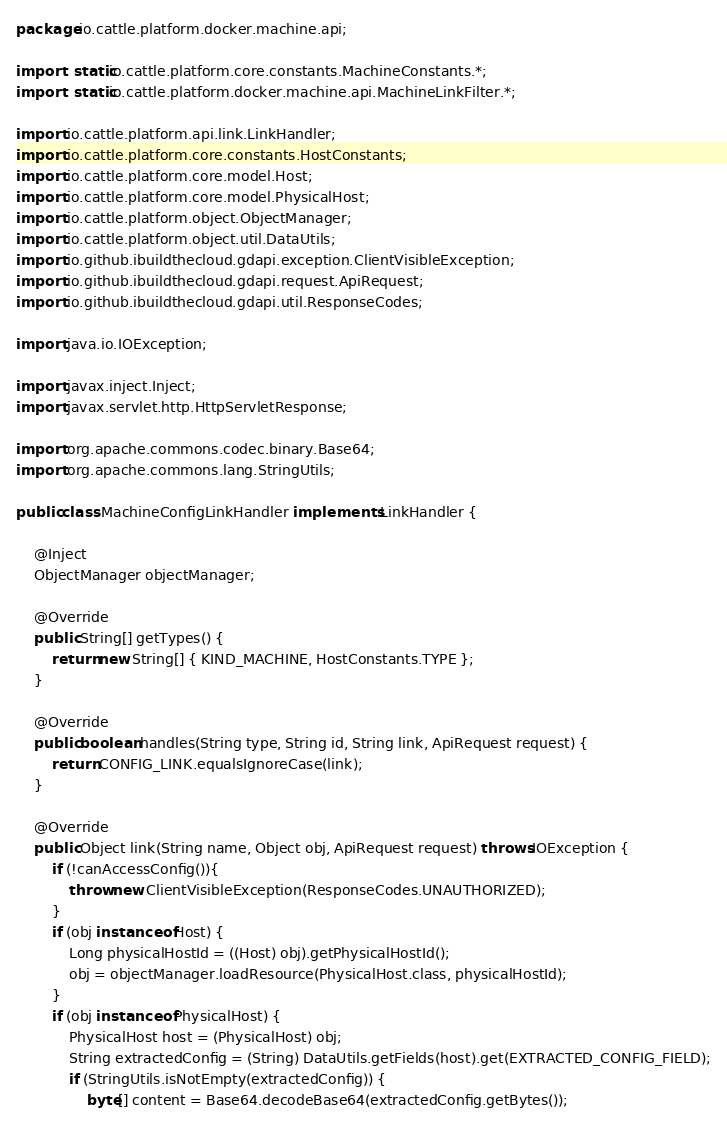<code> <loc_0><loc_0><loc_500><loc_500><_Java_>package io.cattle.platform.docker.machine.api;

import static io.cattle.platform.core.constants.MachineConstants.*;
import static io.cattle.platform.docker.machine.api.MachineLinkFilter.*;

import io.cattle.platform.api.link.LinkHandler;
import io.cattle.platform.core.constants.HostConstants;
import io.cattle.platform.core.model.Host;
import io.cattle.platform.core.model.PhysicalHost;
import io.cattle.platform.object.ObjectManager;
import io.cattle.platform.object.util.DataUtils;
import io.github.ibuildthecloud.gdapi.exception.ClientVisibleException;
import io.github.ibuildthecloud.gdapi.request.ApiRequest;
import io.github.ibuildthecloud.gdapi.util.ResponseCodes;

import java.io.IOException;

import javax.inject.Inject;
import javax.servlet.http.HttpServletResponse;

import org.apache.commons.codec.binary.Base64;
import org.apache.commons.lang.StringUtils;

public class MachineConfigLinkHandler implements LinkHandler {

    @Inject
    ObjectManager objectManager;

    @Override
    public String[] getTypes() {
        return new String[] { KIND_MACHINE, HostConstants.TYPE };
    }

    @Override
    public boolean handles(String type, String id, String link, ApiRequest request) {
        return CONFIG_LINK.equalsIgnoreCase(link);
    }

    @Override
    public Object link(String name, Object obj, ApiRequest request) throws IOException {
        if (!canAccessConfig()){
            throw new ClientVisibleException(ResponseCodes.UNAUTHORIZED);
        }
        if (obj instanceof Host) {
            Long physicalHostId = ((Host) obj).getPhysicalHostId();
            obj = objectManager.loadResource(PhysicalHost.class, physicalHostId);
        }
        if (obj instanceof PhysicalHost) {
            PhysicalHost host = (PhysicalHost) obj;
            String extractedConfig = (String) DataUtils.getFields(host).get(EXTRACTED_CONFIG_FIELD);
            if (StringUtils.isNotEmpty(extractedConfig)) {
                byte[] content = Base64.decodeBase64(extractedConfig.getBytes());</code> 